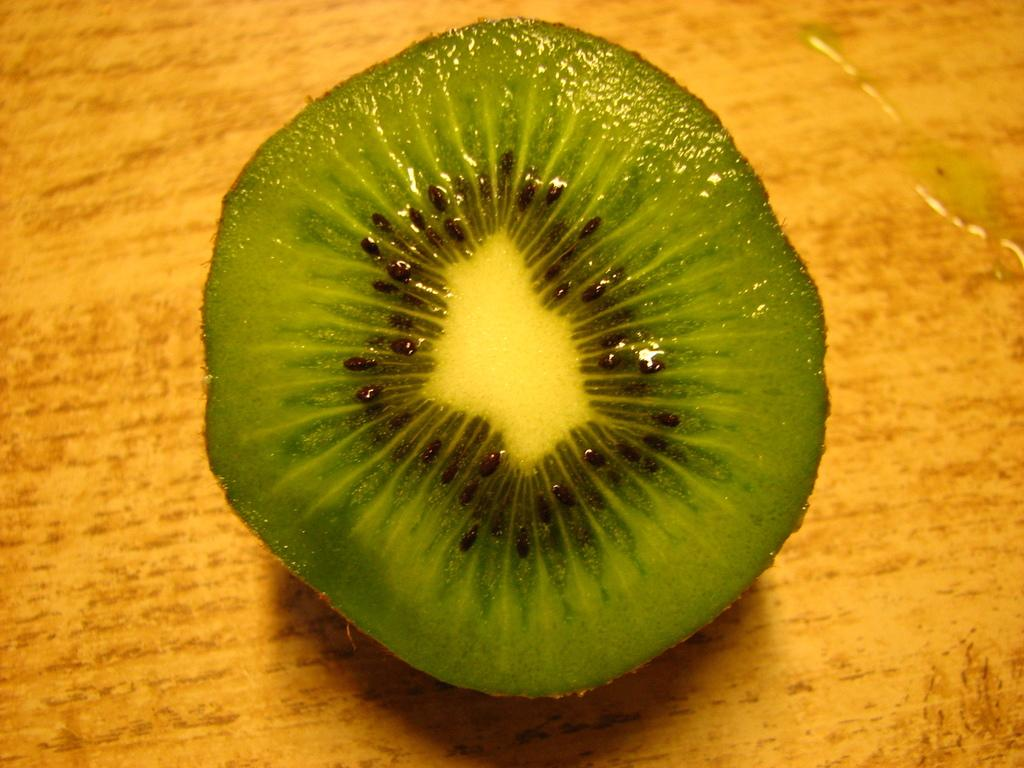What type of food is present in the image? There is a fruit in the image. Where is the fruit located? The fruit is on a platform. What type of brick is used to build the platform in the image? There is no brick present in the image, as the platform is not described in detail. 